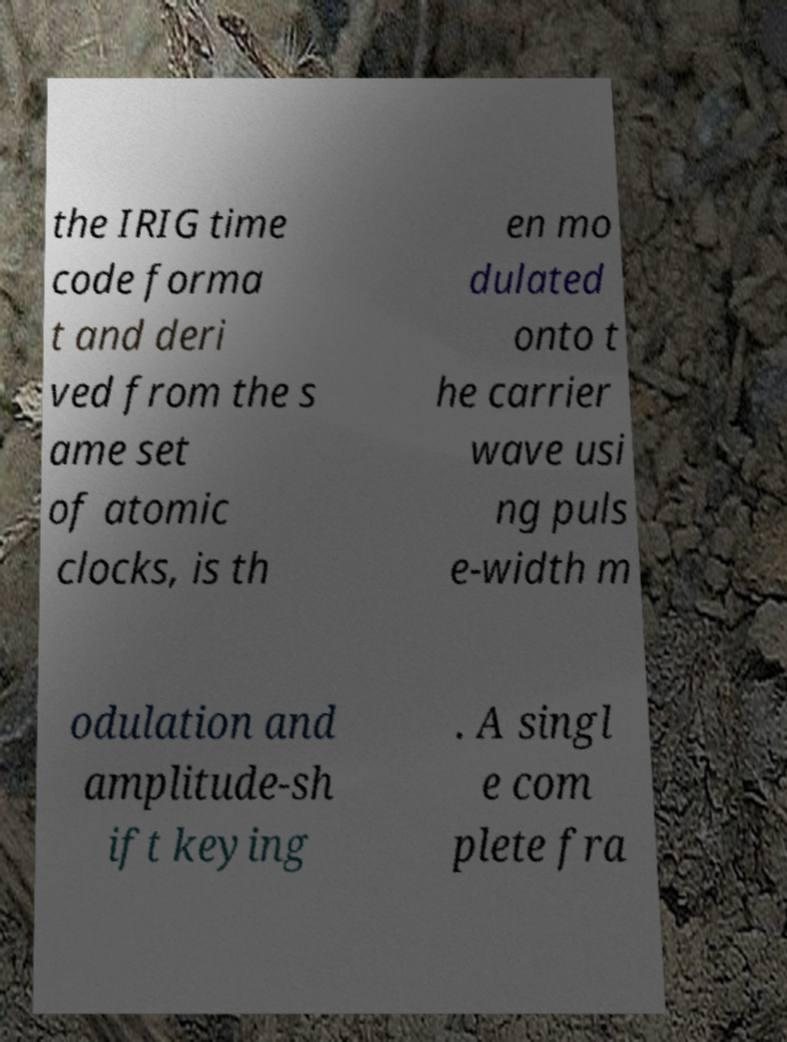I need the written content from this picture converted into text. Can you do that? the IRIG time code forma t and deri ved from the s ame set of atomic clocks, is th en mo dulated onto t he carrier wave usi ng puls e-width m odulation and amplitude-sh ift keying . A singl e com plete fra 